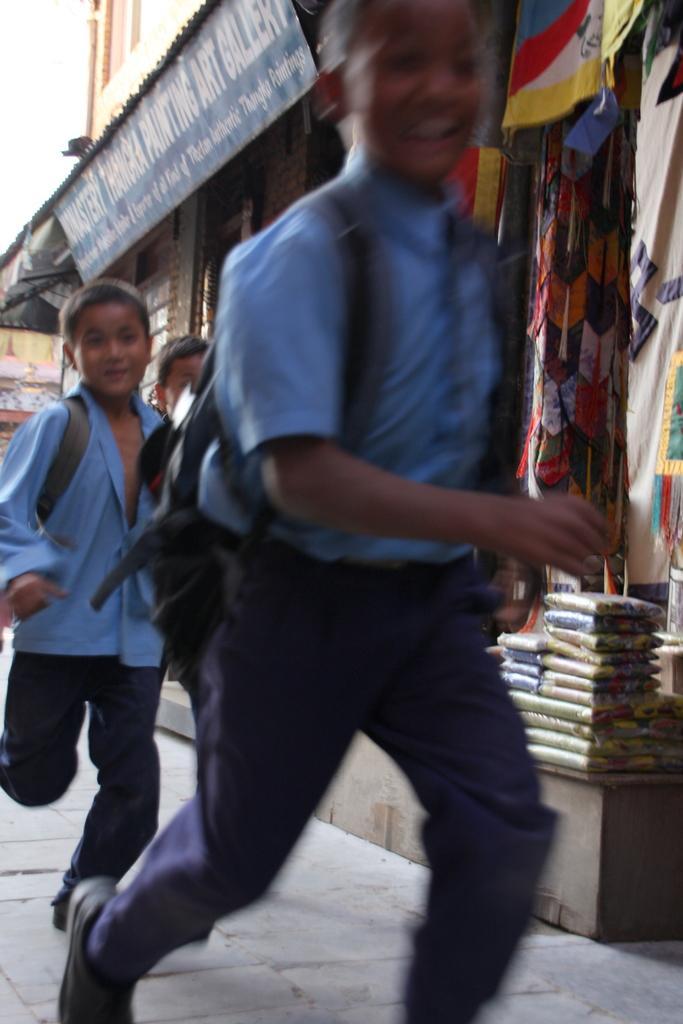How would you summarize this image in a sentence or two? In this image, I can see three people running. I think this looks like a shop with a name board. These are the clothes hanging. I think these are the packets, which are arranged in an order. 